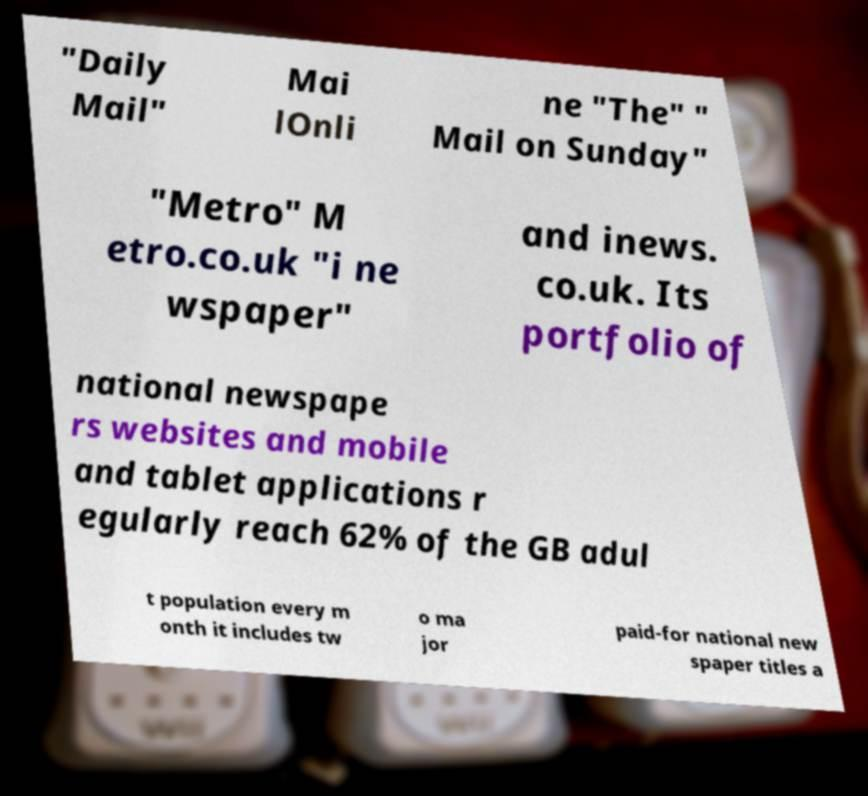Can you read and provide the text displayed in the image?This photo seems to have some interesting text. Can you extract and type it out for me? "Daily Mail" Mai lOnli ne "The" " Mail on Sunday" "Metro" M etro.co.uk "i ne wspaper" and inews. co.uk. Its portfolio of national newspape rs websites and mobile and tablet applications r egularly reach 62% of the GB adul t population every m onth it includes tw o ma jor paid-for national new spaper titles a 